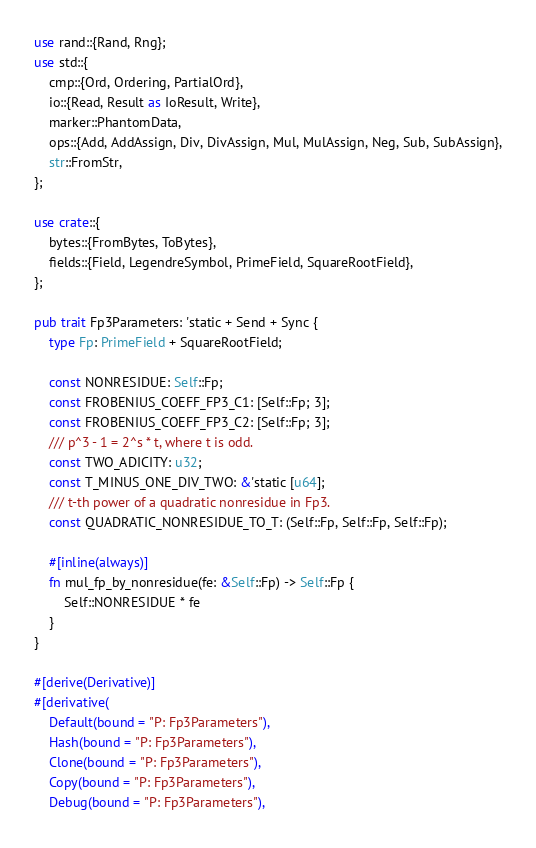Convert code to text. <code><loc_0><loc_0><loc_500><loc_500><_Rust_>use rand::{Rand, Rng};
use std::{
    cmp::{Ord, Ordering, PartialOrd},
    io::{Read, Result as IoResult, Write},
    marker::PhantomData,
    ops::{Add, AddAssign, Div, DivAssign, Mul, MulAssign, Neg, Sub, SubAssign},
    str::FromStr,
};

use crate::{
    bytes::{FromBytes, ToBytes},
    fields::{Field, LegendreSymbol, PrimeField, SquareRootField},
};

pub trait Fp3Parameters: 'static + Send + Sync {
    type Fp: PrimeField + SquareRootField;

    const NONRESIDUE: Self::Fp;
    const FROBENIUS_COEFF_FP3_C1: [Self::Fp; 3];
    const FROBENIUS_COEFF_FP3_C2: [Self::Fp; 3];
    /// p^3 - 1 = 2^s * t, where t is odd.
    const TWO_ADICITY: u32;
    const T_MINUS_ONE_DIV_TWO: &'static [u64];
    /// t-th power of a quadratic nonresidue in Fp3.
    const QUADRATIC_NONRESIDUE_TO_T: (Self::Fp, Self::Fp, Self::Fp);

    #[inline(always)]
    fn mul_fp_by_nonresidue(fe: &Self::Fp) -> Self::Fp {
        Self::NONRESIDUE * fe
    }
}

#[derive(Derivative)]
#[derivative(
    Default(bound = "P: Fp3Parameters"),
    Hash(bound = "P: Fp3Parameters"),
    Clone(bound = "P: Fp3Parameters"),
    Copy(bound = "P: Fp3Parameters"),
    Debug(bound = "P: Fp3Parameters"),</code> 